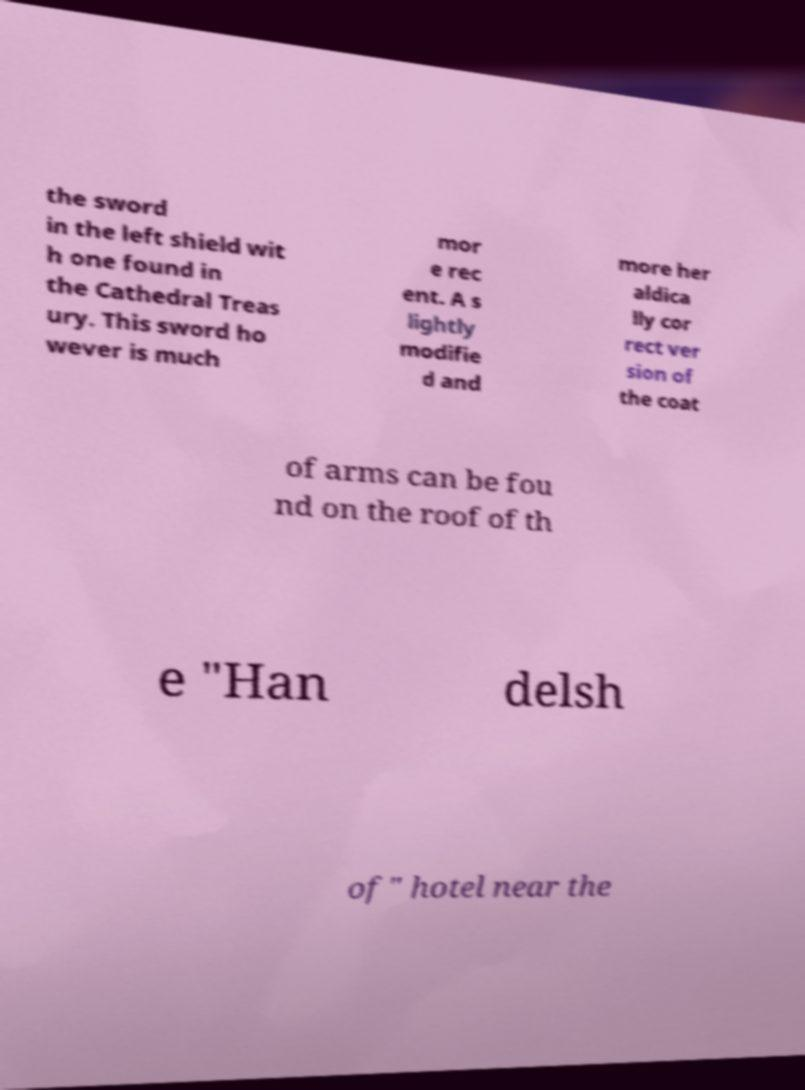Please identify and transcribe the text found in this image. the sword in the left shield wit h one found in the Cathedral Treas ury. This sword ho wever is much mor e rec ent. A s lightly modifie d and more her aldica lly cor rect ver sion of the coat of arms can be fou nd on the roof of th e "Han delsh of" hotel near the 